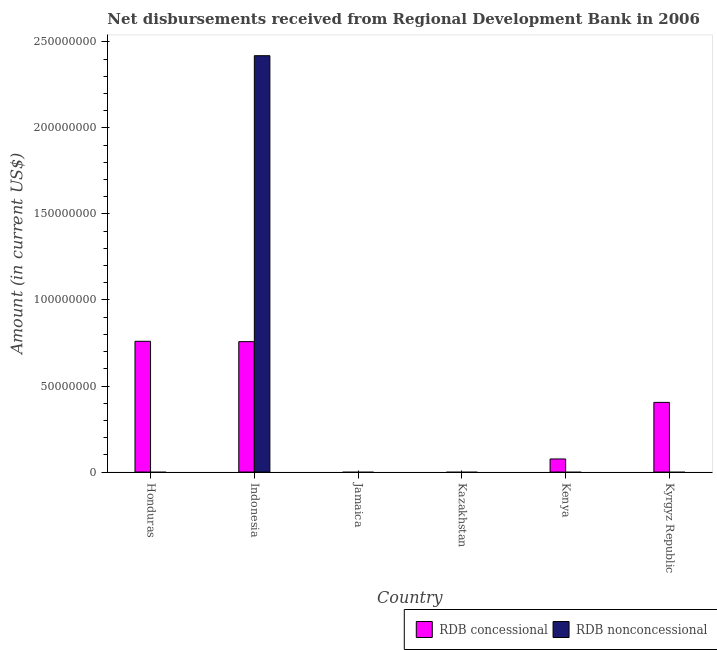How many different coloured bars are there?
Keep it short and to the point. 2. Are the number of bars per tick equal to the number of legend labels?
Your answer should be compact. No. Are the number of bars on each tick of the X-axis equal?
Provide a succinct answer. No. How many bars are there on the 1st tick from the right?
Your response must be concise. 1. What is the label of the 4th group of bars from the left?
Provide a short and direct response. Kazakhstan. In how many cases, is the number of bars for a given country not equal to the number of legend labels?
Your response must be concise. 5. Across all countries, what is the maximum net non concessional disbursements from rdb?
Ensure brevity in your answer.  2.42e+08. In which country was the net concessional disbursements from rdb maximum?
Provide a succinct answer. Honduras. What is the total net non concessional disbursements from rdb in the graph?
Give a very brief answer. 2.42e+08. What is the difference between the net concessional disbursements from rdb in Indonesia and that in Kenya?
Provide a short and direct response. 6.82e+07. What is the difference between the net concessional disbursements from rdb in Indonesia and the net non concessional disbursements from rdb in Honduras?
Your answer should be compact. 7.58e+07. What is the average net non concessional disbursements from rdb per country?
Your response must be concise. 4.03e+07. What is the difference between the net non concessional disbursements from rdb and net concessional disbursements from rdb in Indonesia?
Offer a very short reply. 1.66e+08. In how many countries, is the net non concessional disbursements from rdb greater than 140000000 US$?
Ensure brevity in your answer.  1. What is the ratio of the net concessional disbursements from rdb in Honduras to that in Indonesia?
Offer a terse response. 1. What is the difference between the highest and the lowest net concessional disbursements from rdb?
Offer a very short reply. 7.60e+07. In how many countries, is the net concessional disbursements from rdb greater than the average net concessional disbursements from rdb taken over all countries?
Keep it short and to the point. 3. How many legend labels are there?
Provide a succinct answer. 2. How are the legend labels stacked?
Provide a succinct answer. Horizontal. What is the title of the graph?
Keep it short and to the point. Net disbursements received from Regional Development Bank in 2006. What is the label or title of the X-axis?
Make the answer very short. Country. What is the Amount (in current US$) in RDB concessional in Honduras?
Keep it short and to the point. 7.60e+07. What is the Amount (in current US$) of RDB concessional in Indonesia?
Make the answer very short. 7.58e+07. What is the Amount (in current US$) in RDB nonconcessional in Indonesia?
Give a very brief answer. 2.42e+08. What is the Amount (in current US$) of RDB concessional in Kazakhstan?
Offer a very short reply. 0. What is the Amount (in current US$) in RDB nonconcessional in Kazakhstan?
Ensure brevity in your answer.  0. What is the Amount (in current US$) of RDB concessional in Kenya?
Make the answer very short. 7.59e+06. What is the Amount (in current US$) of RDB nonconcessional in Kenya?
Provide a short and direct response. 0. What is the Amount (in current US$) in RDB concessional in Kyrgyz Republic?
Offer a very short reply. 4.05e+07. What is the Amount (in current US$) of RDB nonconcessional in Kyrgyz Republic?
Make the answer very short. 0. Across all countries, what is the maximum Amount (in current US$) of RDB concessional?
Your response must be concise. 7.60e+07. Across all countries, what is the maximum Amount (in current US$) of RDB nonconcessional?
Your response must be concise. 2.42e+08. Across all countries, what is the minimum Amount (in current US$) in RDB concessional?
Your answer should be compact. 0. Across all countries, what is the minimum Amount (in current US$) of RDB nonconcessional?
Your answer should be very brief. 0. What is the total Amount (in current US$) in RDB concessional in the graph?
Give a very brief answer. 2.00e+08. What is the total Amount (in current US$) in RDB nonconcessional in the graph?
Your answer should be very brief. 2.42e+08. What is the difference between the Amount (in current US$) of RDB concessional in Honduras and that in Indonesia?
Offer a very short reply. 2.10e+05. What is the difference between the Amount (in current US$) of RDB concessional in Honduras and that in Kenya?
Make the answer very short. 6.84e+07. What is the difference between the Amount (in current US$) of RDB concessional in Honduras and that in Kyrgyz Republic?
Ensure brevity in your answer.  3.55e+07. What is the difference between the Amount (in current US$) of RDB concessional in Indonesia and that in Kenya?
Make the answer very short. 6.82e+07. What is the difference between the Amount (in current US$) in RDB concessional in Indonesia and that in Kyrgyz Republic?
Keep it short and to the point. 3.53e+07. What is the difference between the Amount (in current US$) of RDB concessional in Kenya and that in Kyrgyz Republic?
Offer a terse response. -3.29e+07. What is the difference between the Amount (in current US$) in RDB concessional in Honduras and the Amount (in current US$) in RDB nonconcessional in Indonesia?
Your response must be concise. -1.66e+08. What is the average Amount (in current US$) in RDB concessional per country?
Give a very brief answer. 3.33e+07. What is the average Amount (in current US$) in RDB nonconcessional per country?
Keep it short and to the point. 4.03e+07. What is the difference between the Amount (in current US$) in RDB concessional and Amount (in current US$) in RDB nonconcessional in Indonesia?
Provide a succinct answer. -1.66e+08. What is the ratio of the Amount (in current US$) of RDB concessional in Honduras to that in Kenya?
Offer a terse response. 10.01. What is the ratio of the Amount (in current US$) in RDB concessional in Honduras to that in Kyrgyz Republic?
Your response must be concise. 1.88. What is the ratio of the Amount (in current US$) in RDB concessional in Indonesia to that in Kenya?
Your answer should be compact. 9.98. What is the ratio of the Amount (in current US$) in RDB concessional in Indonesia to that in Kyrgyz Republic?
Offer a terse response. 1.87. What is the ratio of the Amount (in current US$) of RDB concessional in Kenya to that in Kyrgyz Republic?
Give a very brief answer. 0.19. What is the difference between the highest and the lowest Amount (in current US$) in RDB concessional?
Keep it short and to the point. 7.60e+07. What is the difference between the highest and the lowest Amount (in current US$) of RDB nonconcessional?
Provide a succinct answer. 2.42e+08. 